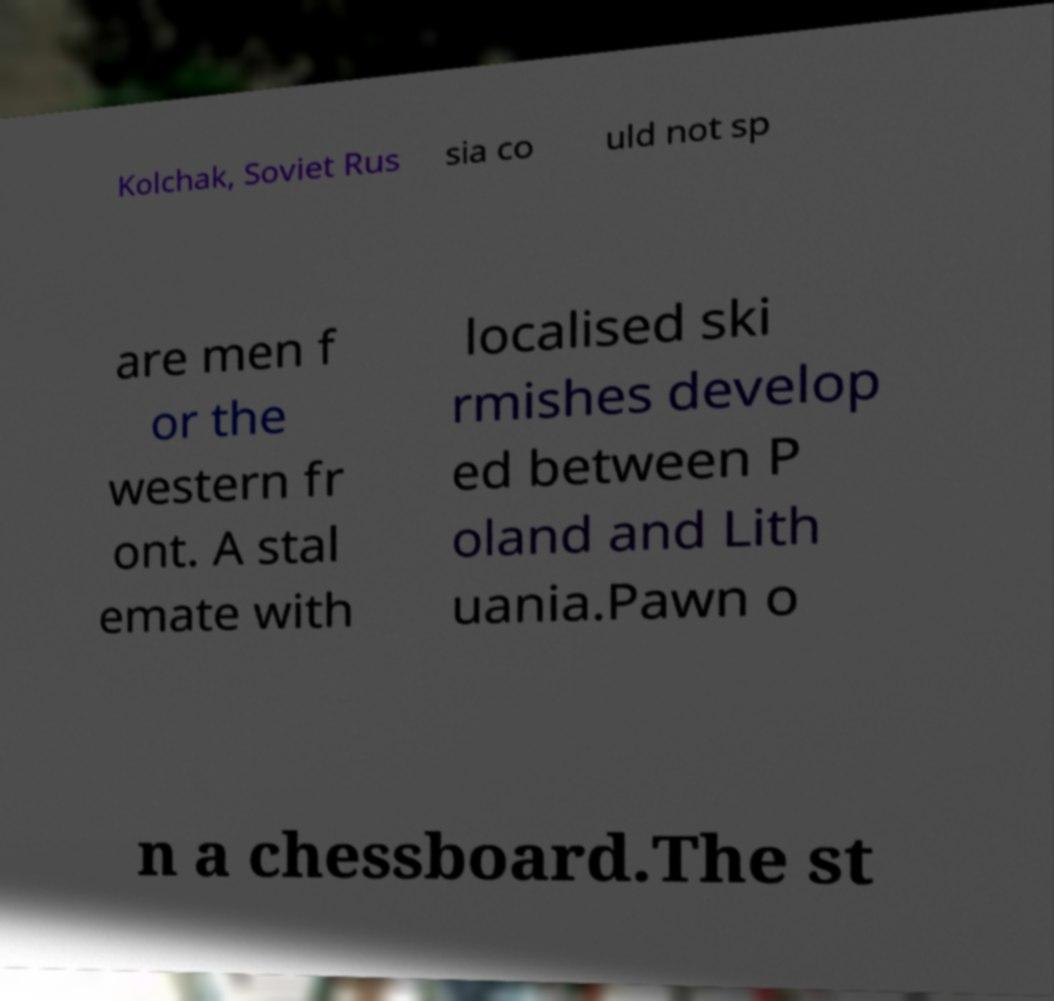For documentation purposes, I need the text within this image transcribed. Could you provide that? Kolchak, Soviet Rus sia co uld not sp are men f or the western fr ont. A stal emate with localised ski rmishes develop ed between P oland and Lith uania.Pawn o n a chessboard.The st 